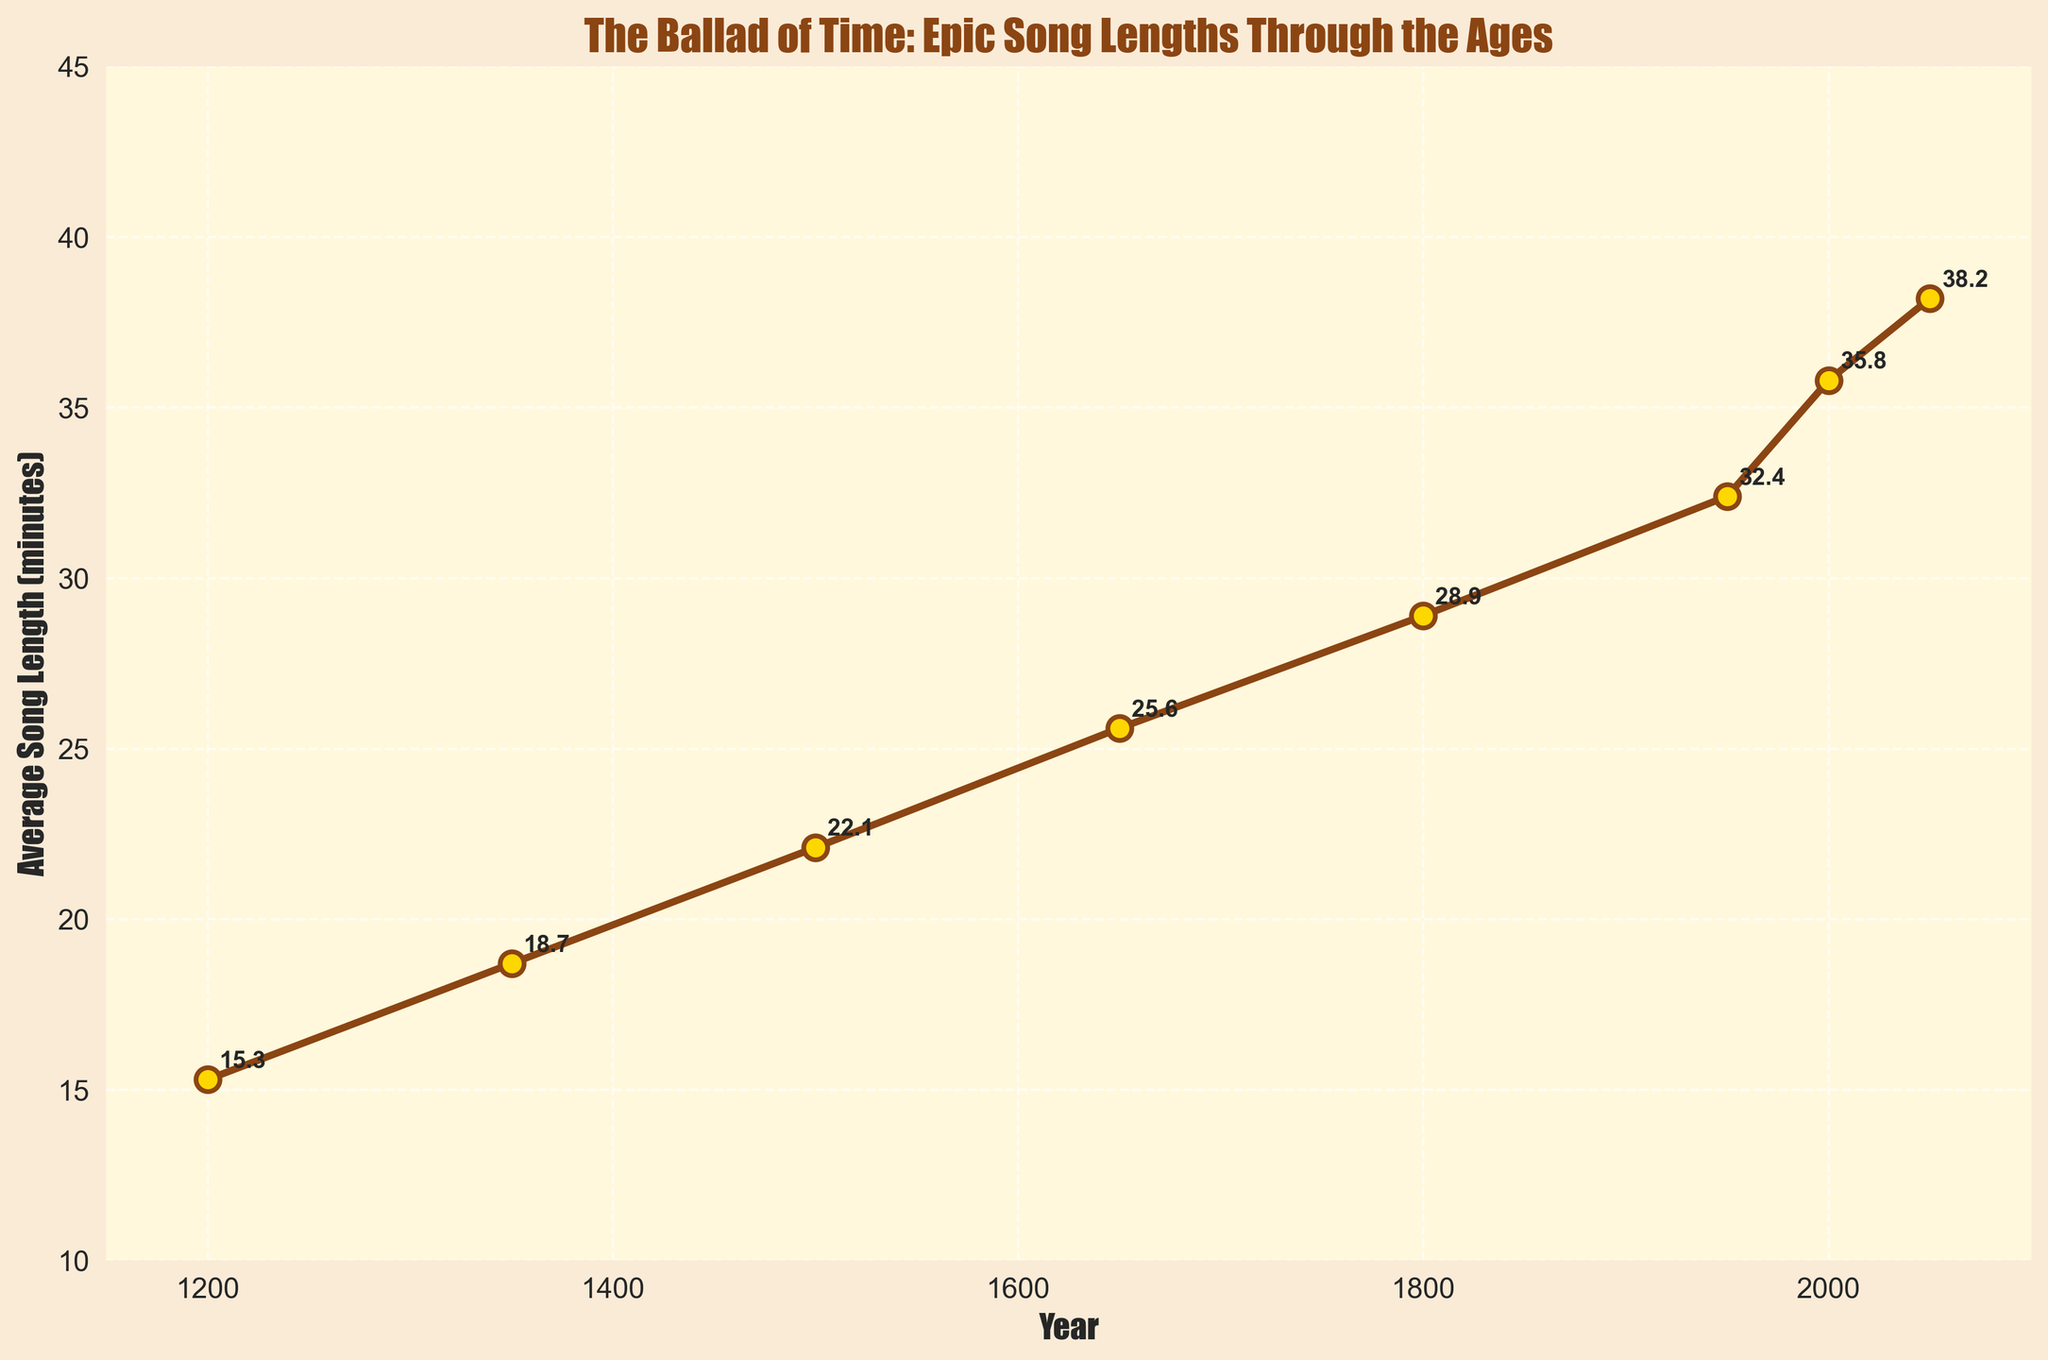What is the average song length in the year 1800? The plot annotates each data point with the song length. Looking at the year 1800, the annotated value is 28.9 minutes.
Answer: 28.9 minutes Between which two centuries did the average song length increase the most? To determine this, we find the difference in song length between each pair of centuries: 1350-1200 (18.7-15.3 = 3.4), 1500-1350 (22.1-18.7 = 3.4), 1650-1500 (25.6-22.1 = 3.5), 1800-1650 (28.9-25.6 = 3.3), 1950-1800 (32.4-28.9 = 3.5), 2000-1950 (35.8-32.4 = 3.4), 2050-2000 (38.2-35.8 = 2.4). The highest increase occurs between 1650-1500 and 1950-1800, both by 3.5 minutes.
Answer: 1650-1500 and 1950-1800 What is the song length difference between the years 1950 and 2000? We find the average song length values for 1950 (32.4 minutes) and 2000 (35.8 minutes). The difference is 35.8 - 32.4 = 3.4 minutes.
Answer: 3.4 minutes What is the trend in average song length from 1200 to 2050? Observing the data points from 1200 (15.3 minutes) to 2050 (38.2 minutes), we see a consistent increase in song length over the years.
Answer: Increasing trend Which year had the smallest average song length? Comparing the data points provided in the chart, the year 1200 had the smallest average song length of 15.3 minutes.
Answer: 1200 What is the average of the average song lengths from the years 1200 to 1500? The lengths for the years are 15.3, 18.7, 22.1. Calculate the sum: 15.3 + 18.7 + 22.1 = 56.1. Then, divide by the number of data points (3): 56.1 / 3 ≈ 18.7.
Answer: 18.7 minutes Did the average song length ever decrease between the years provided? Checking each successive pair of years: 1350 > 1200, 1500 > 1350, 1650 > 1500, 1800 > 1650, 1950 > 1800, 2000 > 1950, 2050 > 2000, we see no decrease.
Answer: No 